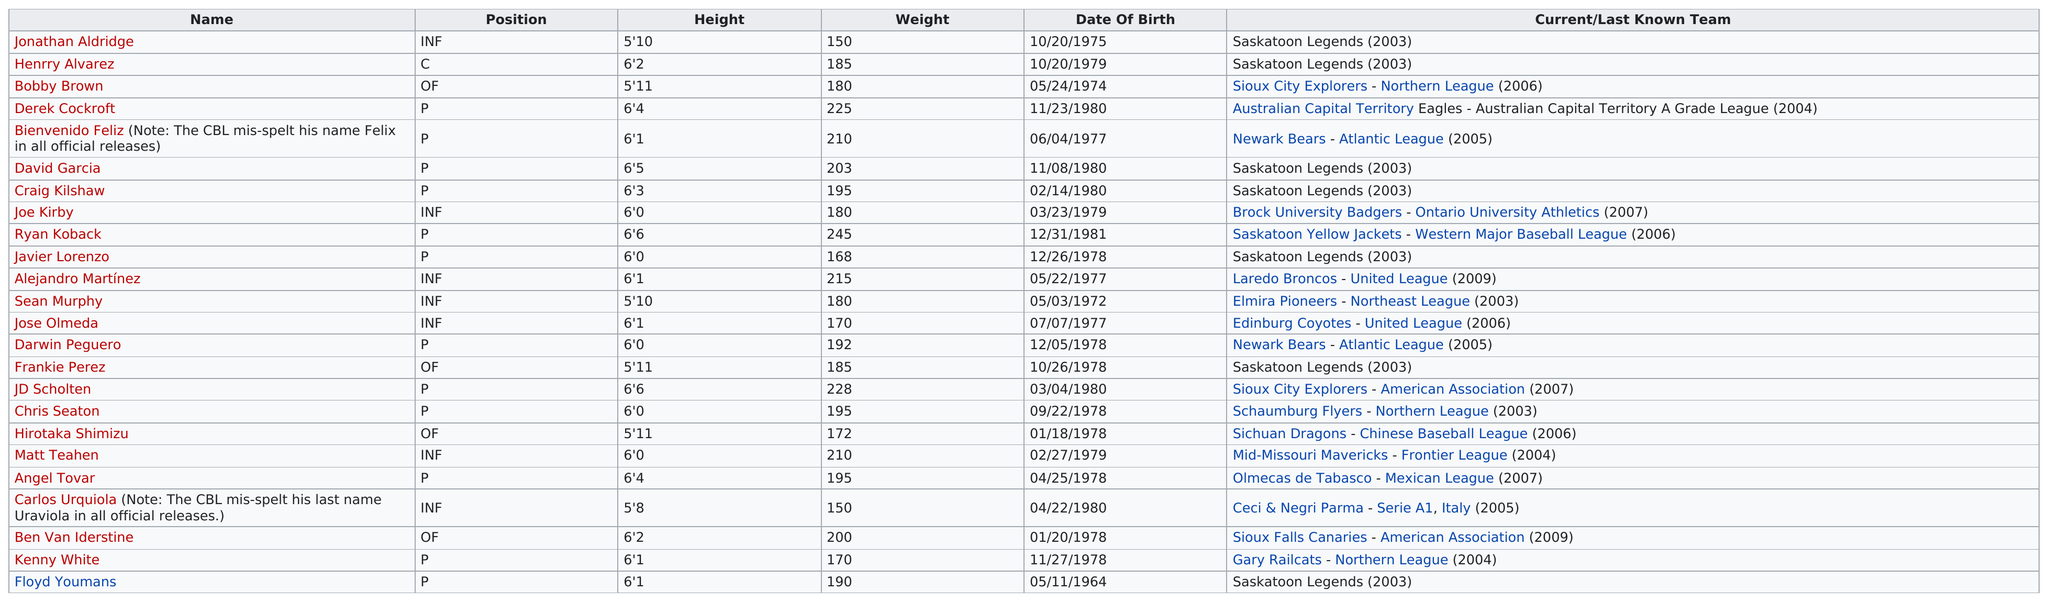Specify some key components in this picture. Of the players born, the majority were born after 1977, specifically 17 of them. It is JD Scholten, the tallest all-time player, who is known for his exceptional height. The Saskatoon Legends team had 24 players who made it onto the all-time roster. The identity of the all-time player who is after Derek Cockroft is Bienvenido Feliz. Floyd Youmans was the first player born to play professional basketball. 